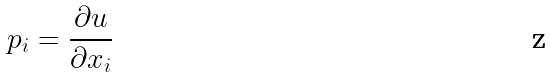<formula> <loc_0><loc_0><loc_500><loc_500>p _ { i } = \frac { \partial u } { \partial x _ { i } }</formula> 